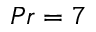Convert formula to latex. <formula><loc_0><loc_0><loc_500><loc_500>P r = 7</formula> 